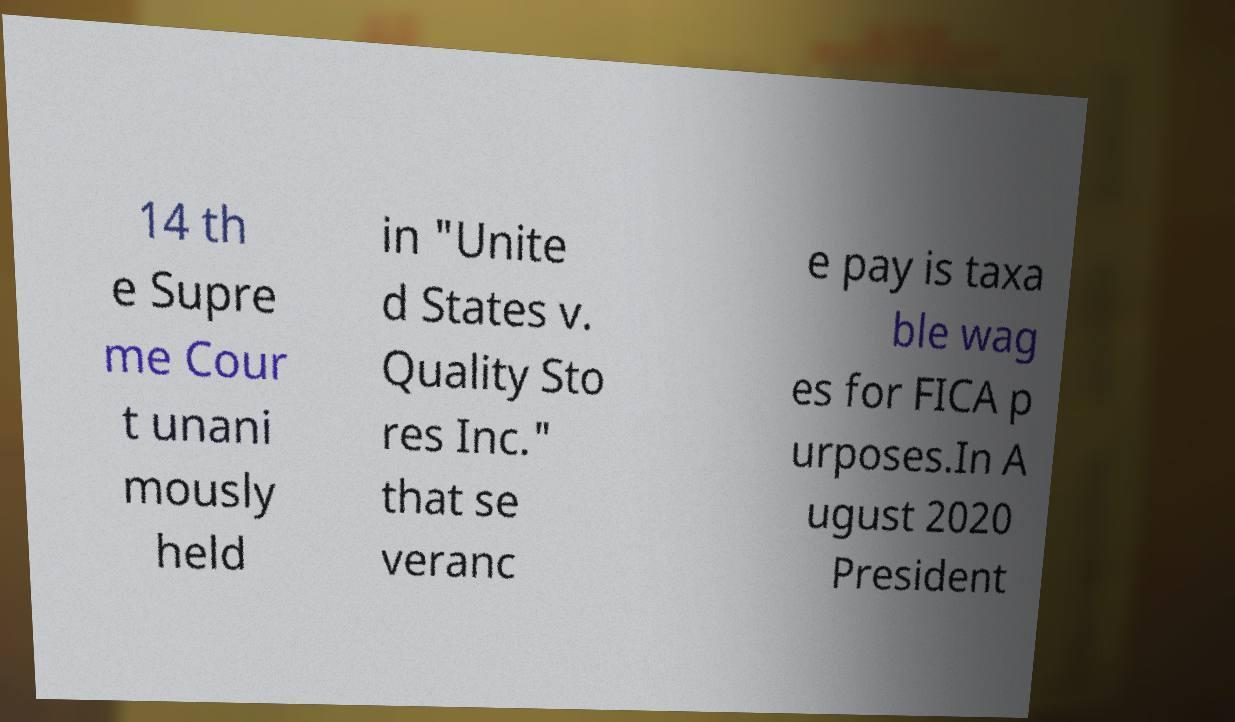Can you accurately transcribe the text from the provided image for me? 14 th e Supre me Cour t unani mously held in "Unite d States v. Quality Sto res Inc." that se veranc e pay is taxa ble wag es for FICA p urposes.In A ugust 2020 President 